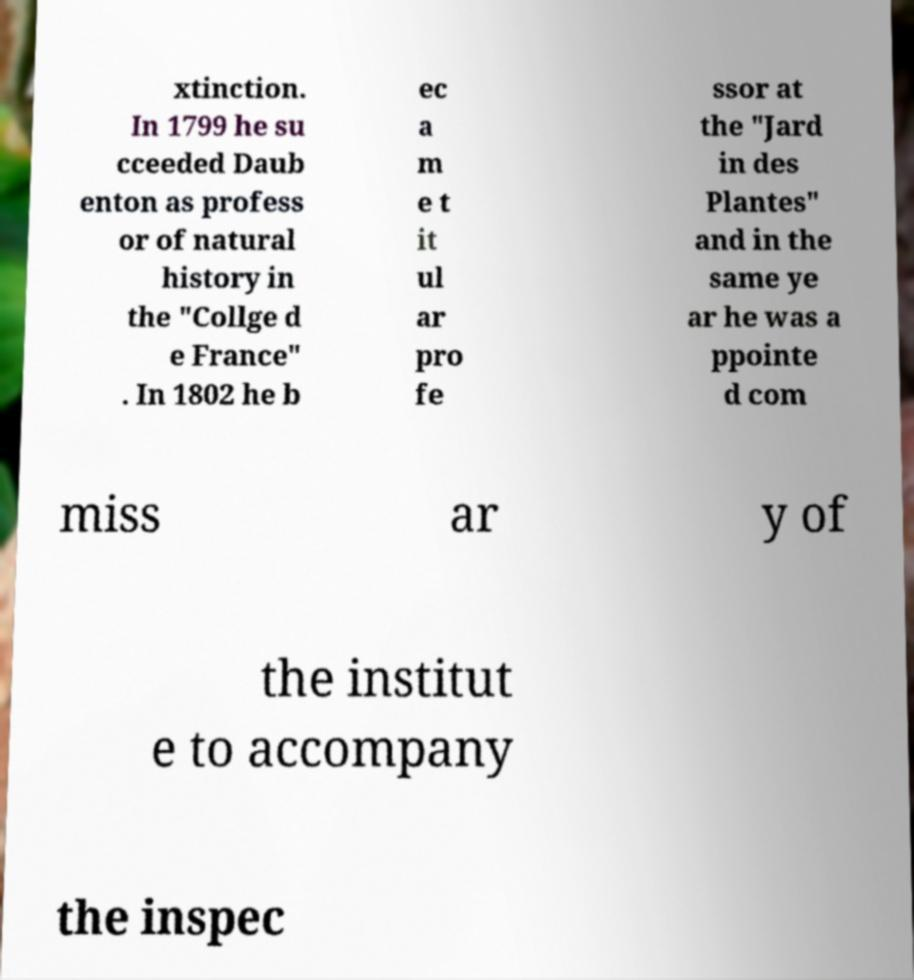What messages or text are displayed in this image? I need them in a readable, typed format. xtinction. In 1799 he su cceeded Daub enton as profess or of natural history in the "Collge d e France" . In 1802 he b ec a m e t it ul ar pro fe ssor at the "Jard in des Plantes" and in the same ye ar he was a ppointe d com miss ar y of the institut e to accompany the inspec 